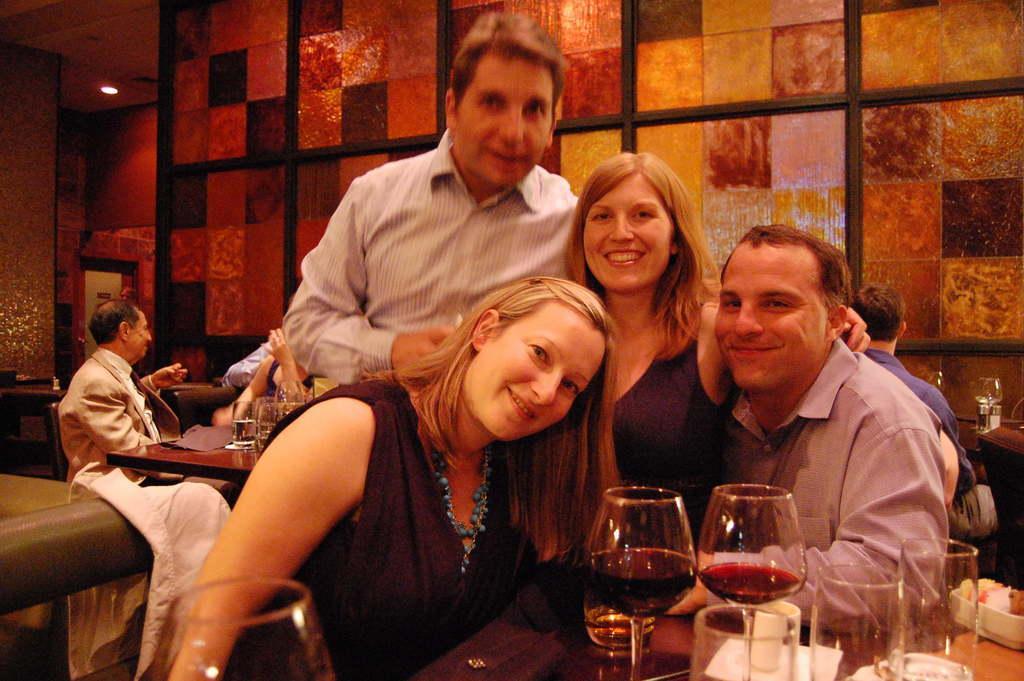Please provide a concise description of this image. This picture shows few people seated on the chairs and a man standing. We see smile on their faces and we see few glasses on the table and we see few tables and glasses on them. We see a roof light. 